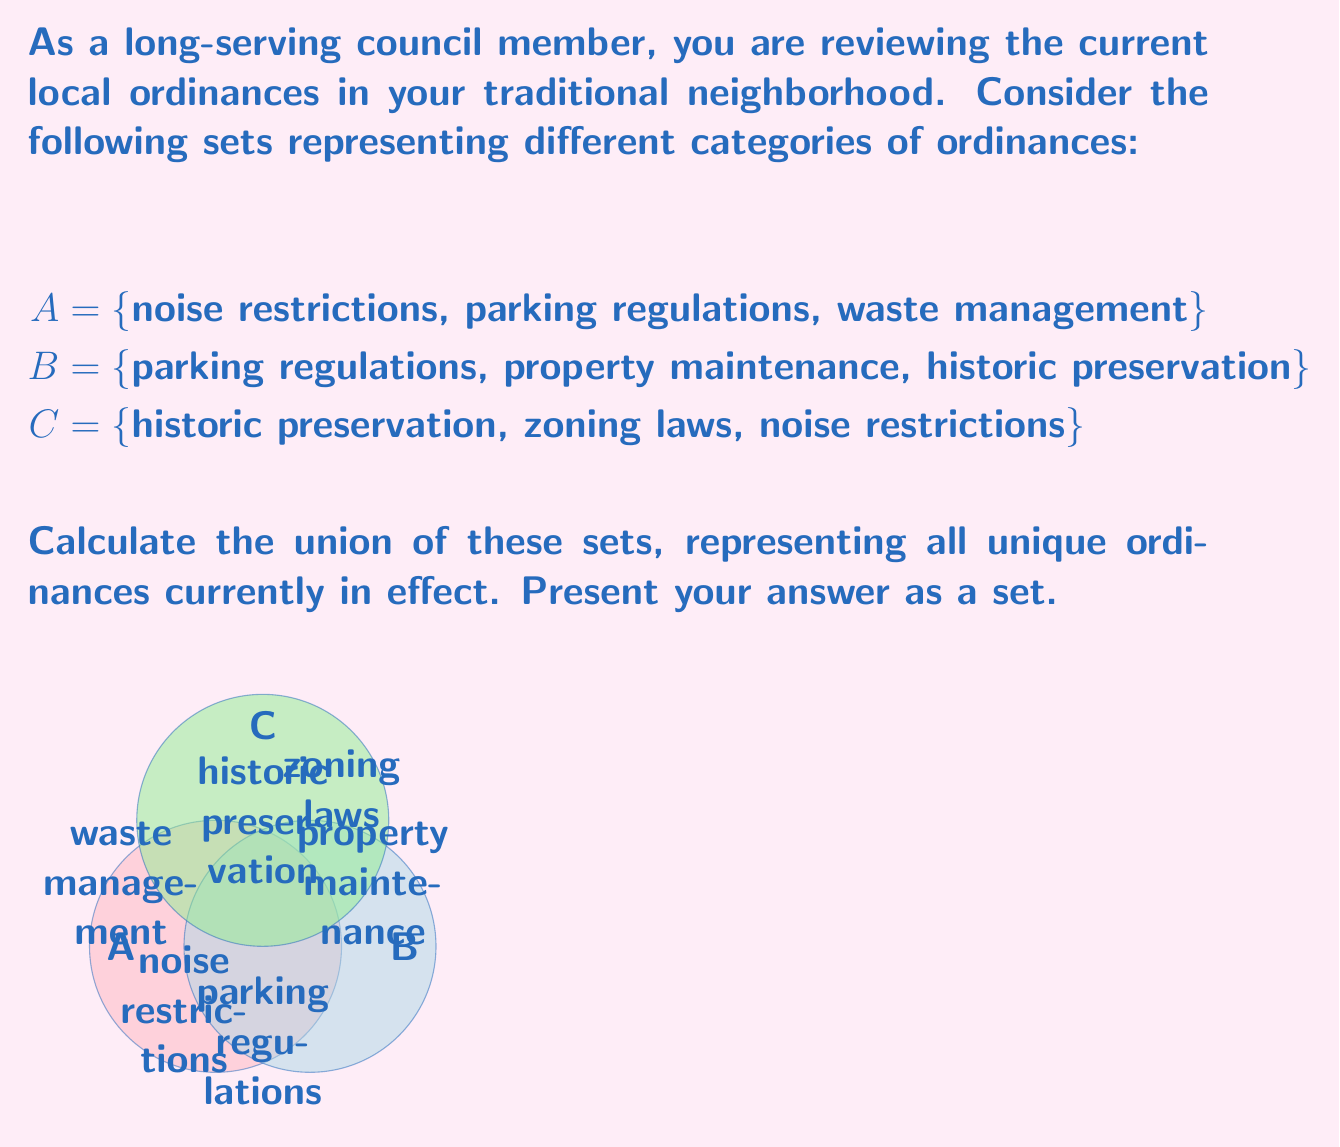Can you answer this question? To calculate the union of sets A, B, and C, we need to combine all unique elements from each set. Let's approach this step-by-step:

1) First, let's list out all elements from each set:
   A = {noise restrictions, parking regulations, waste management}
   B = {parking regulations, property maintenance, historic preservation}
   C = {historic preservation, zoning laws, noise restrictions}

2) Now, let's combine all elements, noting duplicates:
   - noise restrictions (from A and C)
   - parking regulations (from A and B)
   - waste management (from A)
   - property maintenance (from B)
   - historic preservation (from B and C)
   - zoning laws (from C)

3) In set notation, we can write this as:
   $$A \cup B \cup C = \{x | x \in A \text{ or } x \in B \text{ or } x \in C\}$$

4) Listing each unique element only once, we get our final union:
   $$A \cup B \cup C = \{\text{noise restrictions, parking regulations, waste management,}$$
   $$\text{property maintenance, historic preservation, zoning laws}\}$$

This union represents all unique ordinances currently in effect across the three categories.
Answer: {noise restrictions, parking regulations, waste management, property maintenance, historic preservation, zoning laws} 